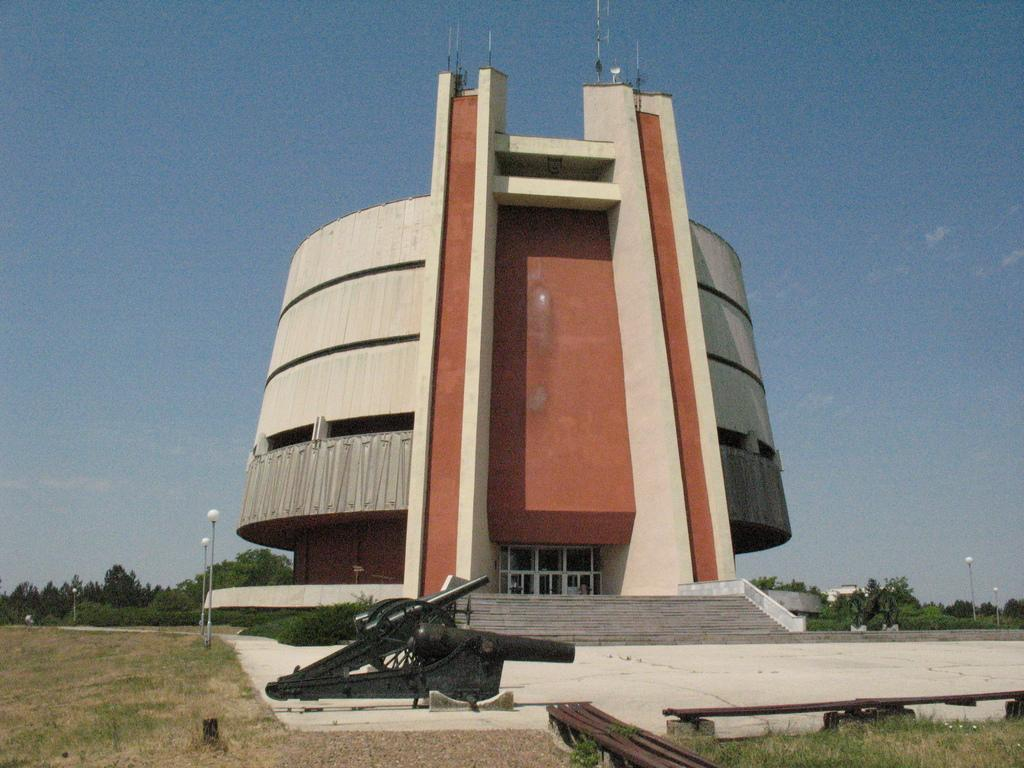What type of structure is visible in the image? There is a building with windows in the image. What feature of the building is mentioned in the facts? The building has a staircase. What objects are on the ground in the image? There are cannons on the ground in the image. What type of seating is available in the image? There are benches in the image. What type of natural environment is present in the image? Grass is present in the image, and there is a group of trees visible. What type of vegetation is present in the image? Plants are visible in the image. What else can be seen in the image? Street poles are present in the image. What is visible in the background of the image? The sky is visible in the image. What type of tin can be seen in the image? There is no tin present in the image. What type of can is visible in the image? There is no can visible in the image. What type of leaf can be seen falling from the trees in the image? There is no leaf falling from the trees in the image. 